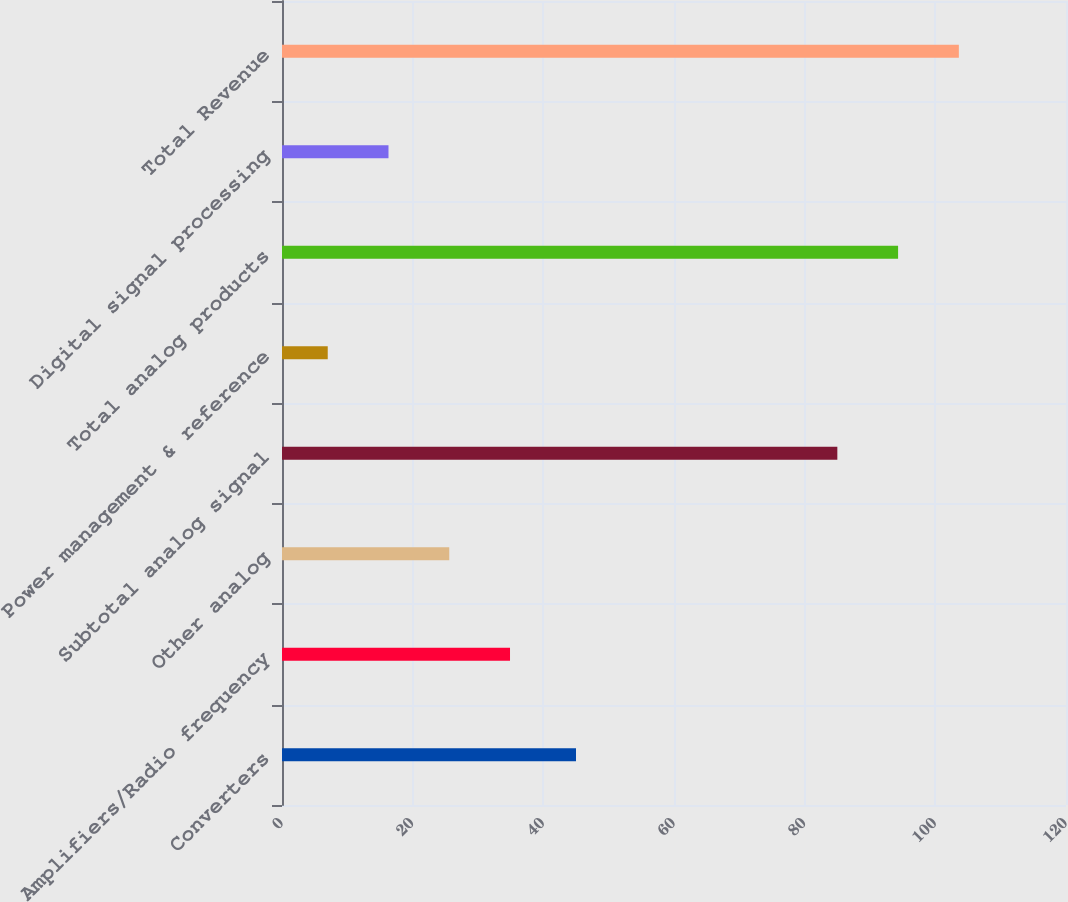Convert chart. <chart><loc_0><loc_0><loc_500><loc_500><bar_chart><fcel>Converters<fcel>Amplifiers/Radio frequency<fcel>Other analog<fcel>Subtotal analog signal<fcel>Power management & reference<fcel>Total analog products<fcel>Digital signal processing<fcel>Total Revenue<nl><fcel>45<fcel>34.9<fcel>25.6<fcel>85<fcel>7<fcel>94.3<fcel>16.3<fcel>103.6<nl></chart> 